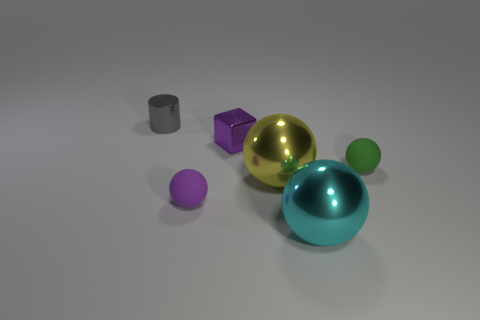There is a tiny object that is the same color as the tiny cube; what material is it?
Give a very brief answer. Rubber. How many yellow balls are there?
Offer a very short reply. 1. There is a big yellow metal object; is it the same shape as the purple object behind the green sphere?
Provide a succinct answer. No. What number of things are big shiny objects or metallic things in front of the shiny cylinder?
Make the answer very short. 3. There is a small green object that is the same shape as the big cyan metal thing; what is its material?
Offer a very short reply. Rubber. There is a object that is in front of the tiny purple matte thing; does it have the same shape as the small green rubber thing?
Your answer should be compact. Yes. Is there anything else that has the same size as the yellow object?
Make the answer very short. Yes. Are there fewer gray cylinders that are in front of the tiny purple block than metal blocks in front of the small green thing?
Provide a short and direct response. No. What number of other things are there of the same shape as the purple matte thing?
Keep it short and to the point. 3. What size is the purple thing that is behind the small rubber object that is on the right side of the small shiny object in front of the gray shiny cylinder?
Give a very brief answer. Small. 